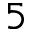Convert formula to latex. <formula><loc_0><loc_0><loc_500><loc_500>5</formula> 